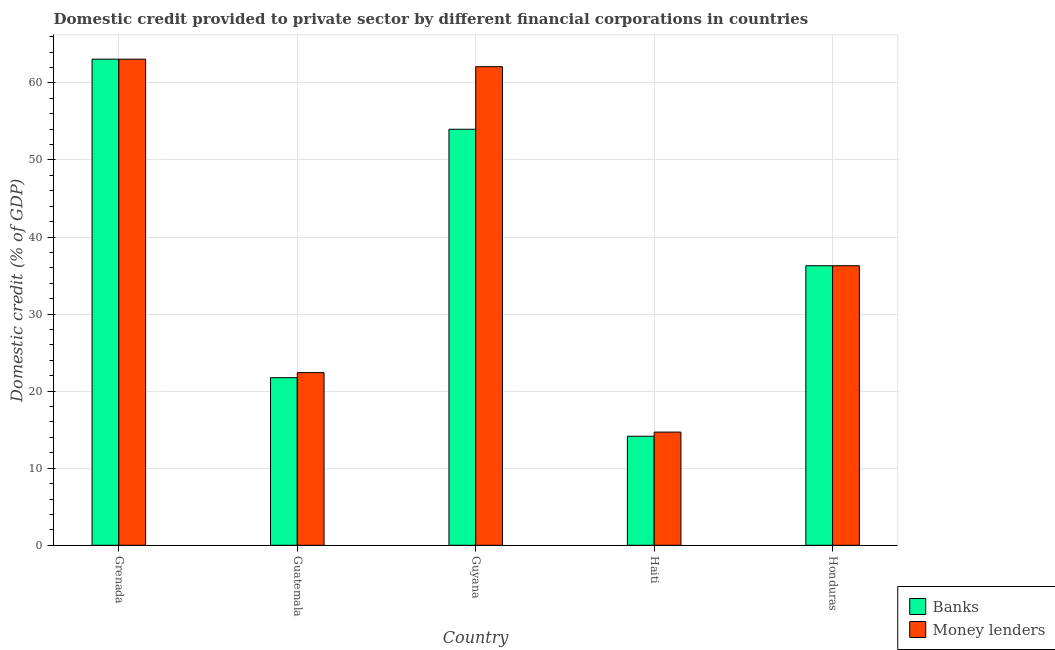How many groups of bars are there?
Your answer should be very brief. 5. Are the number of bars per tick equal to the number of legend labels?
Offer a very short reply. Yes. How many bars are there on the 4th tick from the right?
Keep it short and to the point. 2. What is the label of the 2nd group of bars from the left?
Provide a short and direct response. Guatemala. What is the domestic credit provided by banks in Honduras?
Keep it short and to the point. 36.28. Across all countries, what is the maximum domestic credit provided by money lenders?
Give a very brief answer. 63.08. Across all countries, what is the minimum domestic credit provided by money lenders?
Make the answer very short. 14.69. In which country was the domestic credit provided by money lenders maximum?
Provide a succinct answer. Grenada. In which country was the domestic credit provided by banks minimum?
Ensure brevity in your answer.  Haiti. What is the total domestic credit provided by banks in the graph?
Your answer should be compact. 189.24. What is the difference between the domestic credit provided by money lenders in Grenada and that in Guyana?
Your answer should be very brief. 0.97. What is the difference between the domestic credit provided by money lenders in Guyana and the domestic credit provided by banks in Honduras?
Make the answer very short. 25.83. What is the average domestic credit provided by money lenders per country?
Provide a succinct answer. 39.71. What is the difference between the domestic credit provided by money lenders and domestic credit provided by banks in Guyana?
Your answer should be compact. 8.12. In how many countries, is the domestic credit provided by banks greater than 16 %?
Your response must be concise. 4. What is the ratio of the domestic credit provided by money lenders in Grenada to that in Guyana?
Your answer should be very brief. 1.02. Is the difference between the domestic credit provided by banks in Guatemala and Honduras greater than the difference between the domestic credit provided by money lenders in Guatemala and Honduras?
Provide a succinct answer. No. What is the difference between the highest and the second highest domestic credit provided by money lenders?
Your response must be concise. 0.97. What is the difference between the highest and the lowest domestic credit provided by money lenders?
Your answer should be compact. 48.39. In how many countries, is the domestic credit provided by money lenders greater than the average domestic credit provided by money lenders taken over all countries?
Provide a succinct answer. 2. What does the 2nd bar from the left in Grenada represents?
Ensure brevity in your answer.  Money lenders. What does the 2nd bar from the right in Honduras represents?
Your answer should be very brief. Banks. How many bars are there?
Offer a very short reply. 10. Are all the bars in the graph horizontal?
Offer a terse response. No. How many countries are there in the graph?
Your answer should be compact. 5. Are the values on the major ticks of Y-axis written in scientific E-notation?
Make the answer very short. No. Does the graph contain any zero values?
Provide a short and direct response. No. What is the title of the graph?
Your answer should be very brief. Domestic credit provided to private sector by different financial corporations in countries. What is the label or title of the Y-axis?
Offer a terse response. Domestic credit (% of GDP). What is the Domestic credit (% of GDP) of Banks in Grenada?
Provide a short and direct response. 63.08. What is the Domestic credit (% of GDP) in Money lenders in Grenada?
Keep it short and to the point. 63.08. What is the Domestic credit (% of GDP) of Banks in Guatemala?
Your response must be concise. 21.75. What is the Domestic credit (% of GDP) in Money lenders in Guatemala?
Provide a short and direct response. 22.4. What is the Domestic credit (% of GDP) in Banks in Guyana?
Provide a succinct answer. 53.99. What is the Domestic credit (% of GDP) in Money lenders in Guyana?
Your answer should be very brief. 62.11. What is the Domestic credit (% of GDP) in Banks in Haiti?
Your answer should be very brief. 14.15. What is the Domestic credit (% of GDP) of Money lenders in Haiti?
Your answer should be compact. 14.69. What is the Domestic credit (% of GDP) in Banks in Honduras?
Provide a succinct answer. 36.28. What is the Domestic credit (% of GDP) of Money lenders in Honduras?
Keep it short and to the point. 36.28. Across all countries, what is the maximum Domestic credit (% of GDP) in Banks?
Ensure brevity in your answer.  63.08. Across all countries, what is the maximum Domestic credit (% of GDP) in Money lenders?
Your response must be concise. 63.08. Across all countries, what is the minimum Domestic credit (% of GDP) in Banks?
Offer a terse response. 14.15. Across all countries, what is the minimum Domestic credit (% of GDP) in Money lenders?
Provide a succinct answer. 14.69. What is the total Domestic credit (% of GDP) in Banks in the graph?
Your response must be concise. 189.24. What is the total Domestic credit (% of GDP) in Money lenders in the graph?
Provide a short and direct response. 198.56. What is the difference between the Domestic credit (% of GDP) of Banks in Grenada and that in Guatemala?
Offer a terse response. 41.33. What is the difference between the Domestic credit (% of GDP) of Money lenders in Grenada and that in Guatemala?
Your answer should be compact. 40.68. What is the difference between the Domestic credit (% of GDP) of Banks in Grenada and that in Guyana?
Your answer should be very brief. 9.09. What is the difference between the Domestic credit (% of GDP) in Money lenders in Grenada and that in Guyana?
Your answer should be compact. 0.97. What is the difference between the Domestic credit (% of GDP) of Banks in Grenada and that in Haiti?
Offer a very short reply. 48.93. What is the difference between the Domestic credit (% of GDP) of Money lenders in Grenada and that in Haiti?
Your answer should be very brief. 48.39. What is the difference between the Domestic credit (% of GDP) in Banks in Grenada and that in Honduras?
Offer a very short reply. 26.8. What is the difference between the Domestic credit (% of GDP) in Money lenders in Grenada and that in Honduras?
Offer a terse response. 26.8. What is the difference between the Domestic credit (% of GDP) of Banks in Guatemala and that in Guyana?
Your answer should be compact. -32.24. What is the difference between the Domestic credit (% of GDP) of Money lenders in Guatemala and that in Guyana?
Offer a terse response. -39.7. What is the difference between the Domestic credit (% of GDP) in Banks in Guatemala and that in Haiti?
Give a very brief answer. 7.6. What is the difference between the Domestic credit (% of GDP) of Money lenders in Guatemala and that in Haiti?
Make the answer very short. 7.71. What is the difference between the Domestic credit (% of GDP) of Banks in Guatemala and that in Honduras?
Offer a very short reply. -14.53. What is the difference between the Domestic credit (% of GDP) in Money lenders in Guatemala and that in Honduras?
Provide a succinct answer. -13.87. What is the difference between the Domestic credit (% of GDP) in Banks in Guyana and that in Haiti?
Ensure brevity in your answer.  39.84. What is the difference between the Domestic credit (% of GDP) of Money lenders in Guyana and that in Haiti?
Offer a very short reply. 47.42. What is the difference between the Domestic credit (% of GDP) in Banks in Guyana and that in Honduras?
Give a very brief answer. 17.71. What is the difference between the Domestic credit (% of GDP) in Money lenders in Guyana and that in Honduras?
Provide a short and direct response. 25.83. What is the difference between the Domestic credit (% of GDP) of Banks in Haiti and that in Honduras?
Your answer should be compact. -22.13. What is the difference between the Domestic credit (% of GDP) of Money lenders in Haiti and that in Honduras?
Provide a short and direct response. -21.59. What is the difference between the Domestic credit (% of GDP) of Banks in Grenada and the Domestic credit (% of GDP) of Money lenders in Guatemala?
Ensure brevity in your answer.  40.68. What is the difference between the Domestic credit (% of GDP) of Banks in Grenada and the Domestic credit (% of GDP) of Money lenders in Guyana?
Provide a short and direct response. 0.97. What is the difference between the Domestic credit (% of GDP) of Banks in Grenada and the Domestic credit (% of GDP) of Money lenders in Haiti?
Make the answer very short. 48.39. What is the difference between the Domestic credit (% of GDP) of Banks in Grenada and the Domestic credit (% of GDP) of Money lenders in Honduras?
Offer a very short reply. 26.8. What is the difference between the Domestic credit (% of GDP) in Banks in Guatemala and the Domestic credit (% of GDP) in Money lenders in Guyana?
Offer a terse response. -40.36. What is the difference between the Domestic credit (% of GDP) in Banks in Guatemala and the Domestic credit (% of GDP) in Money lenders in Haiti?
Your response must be concise. 7.06. What is the difference between the Domestic credit (% of GDP) in Banks in Guatemala and the Domestic credit (% of GDP) in Money lenders in Honduras?
Ensure brevity in your answer.  -14.53. What is the difference between the Domestic credit (% of GDP) in Banks in Guyana and the Domestic credit (% of GDP) in Money lenders in Haiti?
Keep it short and to the point. 39.3. What is the difference between the Domestic credit (% of GDP) in Banks in Guyana and the Domestic credit (% of GDP) in Money lenders in Honduras?
Ensure brevity in your answer.  17.71. What is the difference between the Domestic credit (% of GDP) in Banks in Haiti and the Domestic credit (% of GDP) in Money lenders in Honduras?
Provide a short and direct response. -22.13. What is the average Domestic credit (% of GDP) in Banks per country?
Make the answer very short. 37.85. What is the average Domestic credit (% of GDP) of Money lenders per country?
Provide a short and direct response. 39.71. What is the difference between the Domestic credit (% of GDP) of Banks and Domestic credit (% of GDP) of Money lenders in Guatemala?
Ensure brevity in your answer.  -0.66. What is the difference between the Domestic credit (% of GDP) in Banks and Domestic credit (% of GDP) in Money lenders in Guyana?
Offer a terse response. -8.12. What is the difference between the Domestic credit (% of GDP) in Banks and Domestic credit (% of GDP) in Money lenders in Haiti?
Keep it short and to the point. -0.54. What is the difference between the Domestic credit (% of GDP) of Banks and Domestic credit (% of GDP) of Money lenders in Honduras?
Provide a succinct answer. -0. What is the ratio of the Domestic credit (% of GDP) in Banks in Grenada to that in Guatemala?
Offer a very short reply. 2.9. What is the ratio of the Domestic credit (% of GDP) in Money lenders in Grenada to that in Guatemala?
Your response must be concise. 2.82. What is the ratio of the Domestic credit (% of GDP) of Banks in Grenada to that in Guyana?
Ensure brevity in your answer.  1.17. What is the ratio of the Domestic credit (% of GDP) of Money lenders in Grenada to that in Guyana?
Provide a short and direct response. 1.02. What is the ratio of the Domestic credit (% of GDP) of Banks in Grenada to that in Haiti?
Your answer should be compact. 4.46. What is the ratio of the Domestic credit (% of GDP) in Money lenders in Grenada to that in Haiti?
Give a very brief answer. 4.29. What is the ratio of the Domestic credit (% of GDP) of Banks in Grenada to that in Honduras?
Ensure brevity in your answer.  1.74. What is the ratio of the Domestic credit (% of GDP) of Money lenders in Grenada to that in Honduras?
Make the answer very short. 1.74. What is the ratio of the Domestic credit (% of GDP) in Banks in Guatemala to that in Guyana?
Your answer should be very brief. 0.4. What is the ratio of the Domestic credit (% of GDP) in Money lenders in Guatemala to that in Guyana?
Give a very brief answer. 0.36. What is the ratio of the Domestic credit (% of GDP) in Banks in Guatemala to that in Haiti?
Your answer should be very brief. 1.54. What is the ratio of the Domestic credit (% of GDP) in Money lenders in Guatemala to that in Haiti?
Your answer should be compact. 1.53. What is the ratio of the Domestic credit (% of GDP) of Banks in Guatemala to that in Honduras?
Offer a very short reply. 0.6. What is the ratio of the Domestic credit (% of GDP) in Money lenders in Guatemala to that in Honduras?
Offer a terse response. 0.62. What is the ratio of the Domestic credit (% of GDP) of Banks in Guyana to that in Haiti?
Provide a succinct answer. 3.82. What is the ratio of the Domestic credit (% of GDP) in Money lenders in Guyana to that in Haiti?
Ensure brevity in your answer.  4.23. What is the ratio of the Domestic credit (% of GDP) in Banks in Guyana to that in Honduras?
Keep it short and to the point. 1.49. What is the ratio of the Domestic credit (% of GDP) in Money lenders in Guyana to that in Honduras?
Give a very brief answer. 1.71. What is the ratio of the Domestic credit (% of GDP) of Banks in Haiti to that in Honduras?
Ensure brevity in your answer.  0.39. What is the ratio of the Domestic credit (% of GDP) in Money lenders in Haiti to that in Honduras?
Offer a terse response. 0.4. What is the difference between the highest and the second highest Domestic credit (% of GDP) of Banks?
Your answer should be compact. 9.09. What is the difference between the highest and the second highest Domestic credit (% of GDP) of Money lenders?
Give a very brief answer. 0.97. What is the difference between the highest and the lowest Domestic credit (% of GDP) in Banks?
Ensure brevity in your answer.  48.93. What is the difference between the highest and the lowest Domestic credit (% of GDP) of Money lenders?
Ensure brevity in your answer.  48.39. 